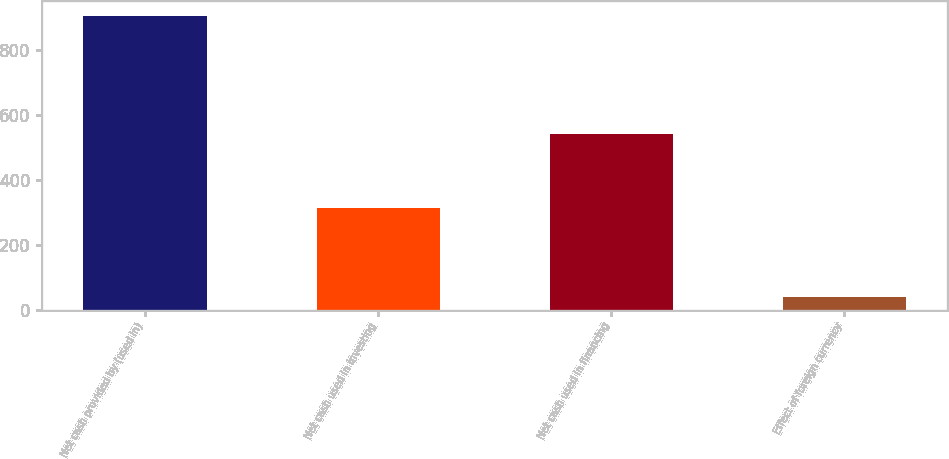<chart> <loc_0><loc_0><loc_500><loc_500><bar_chart><fcel>Net cash provided by (used in)<fcel>Net cash used in investing<fcel>Net cash used in financing<fcel>Effect of foreign currency<nl><fcel>906.9<fcel>314.8<fcel>540.9<fcel>39.2<nl></chart> 